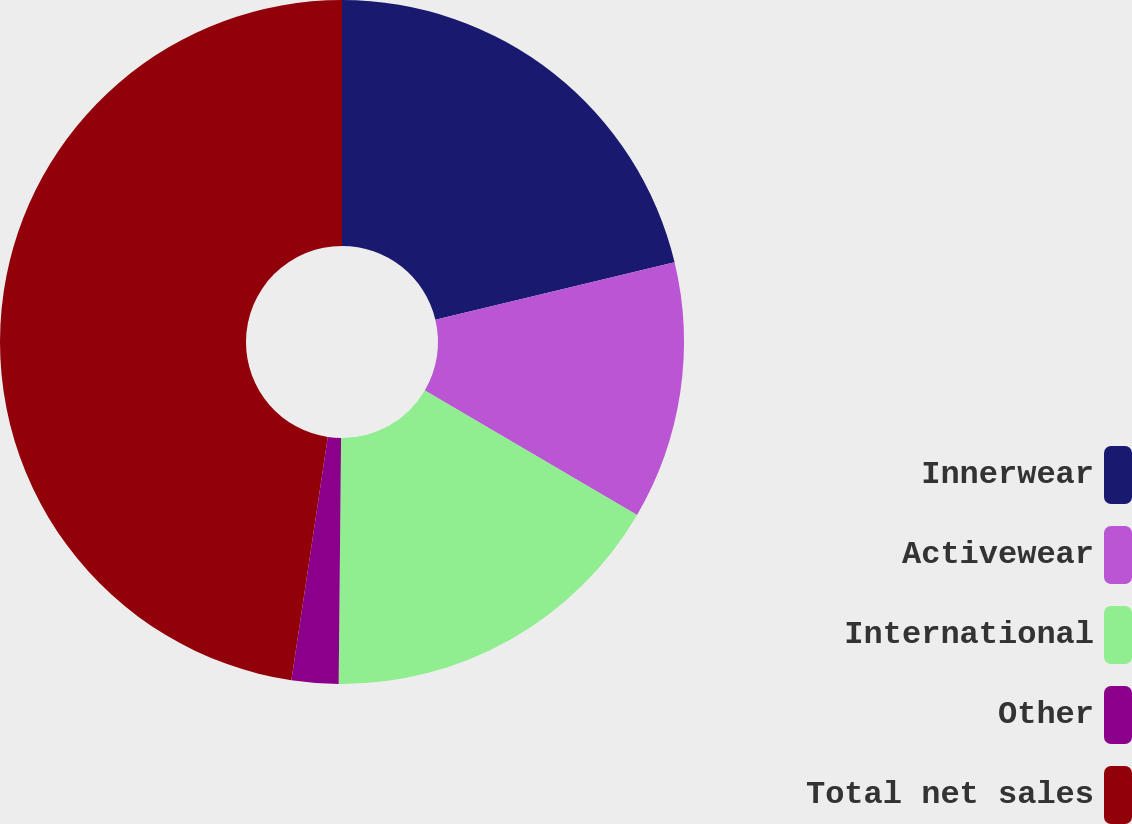Convert chart. <chart><loc_0><loc_0><loc_500><loc_500><pie_chart><fcel>Innerwear<fcel>Activewear<fcel>International<fcel>Other<fcel>Total net sales<nl><fcel>21.26%<fcel>12.18%<fcel>16.72%<fcel>2.21%<fcel>47.64%<nl></chart> 